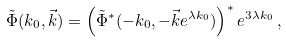<formula> <loc_0><loc_0><loc_500><loc_500>\tilde { \Phi } ( k _ { 0 } , \vec { k } ) = \left ( \tilde { \Phi } ^ { * } ( - k _ { 0 } , - \vec { k } e ^ { \lambda k _ { 0 } } ) \right ) ^ { * } e ^ { 3 \lambda k _ { 0 } } \, ,</formula> 